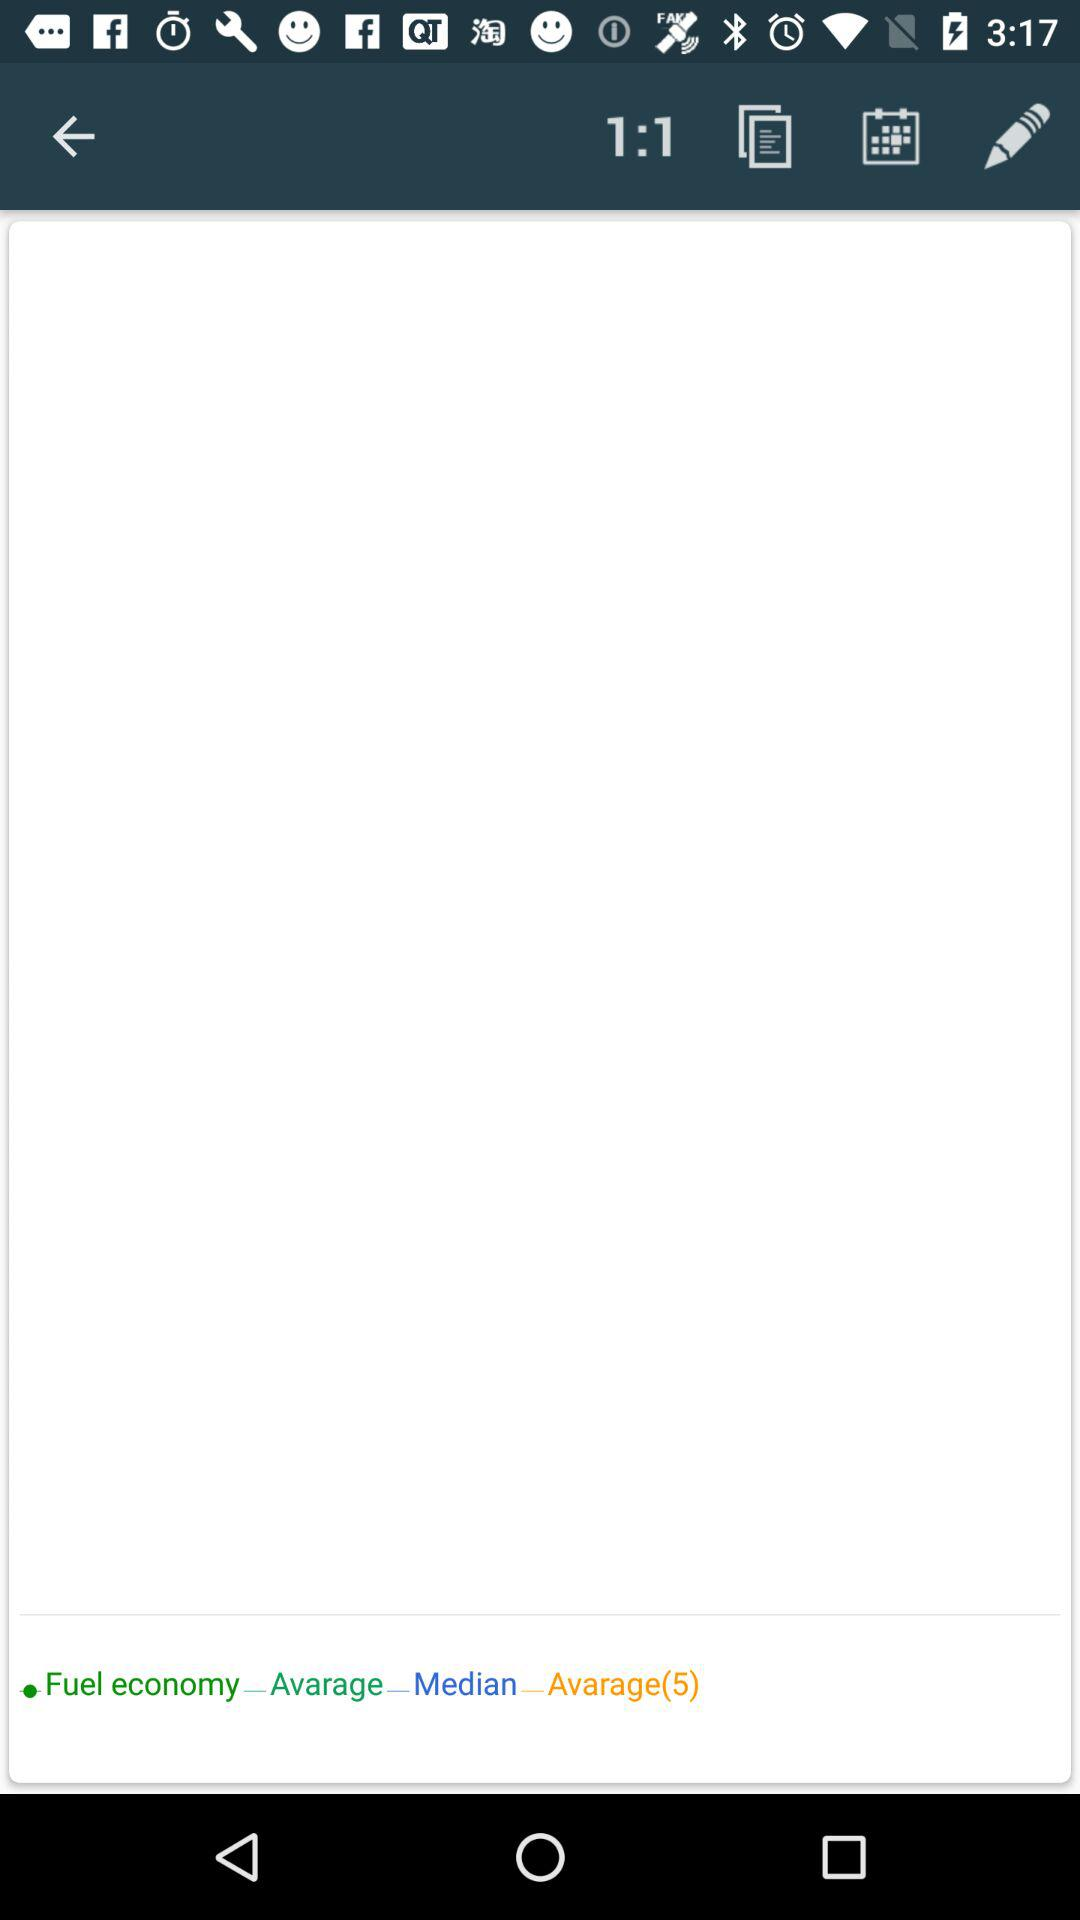How many fuel economy options are there?
Answer the question using a single word or phrase. 3 